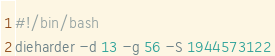Convert code to text. <code><loc_0><loc_0><loc_500><loc_500><_Bash_>#!/bin/bash
dieharder -d 13 -g 56 -S 1944573122
</code> 